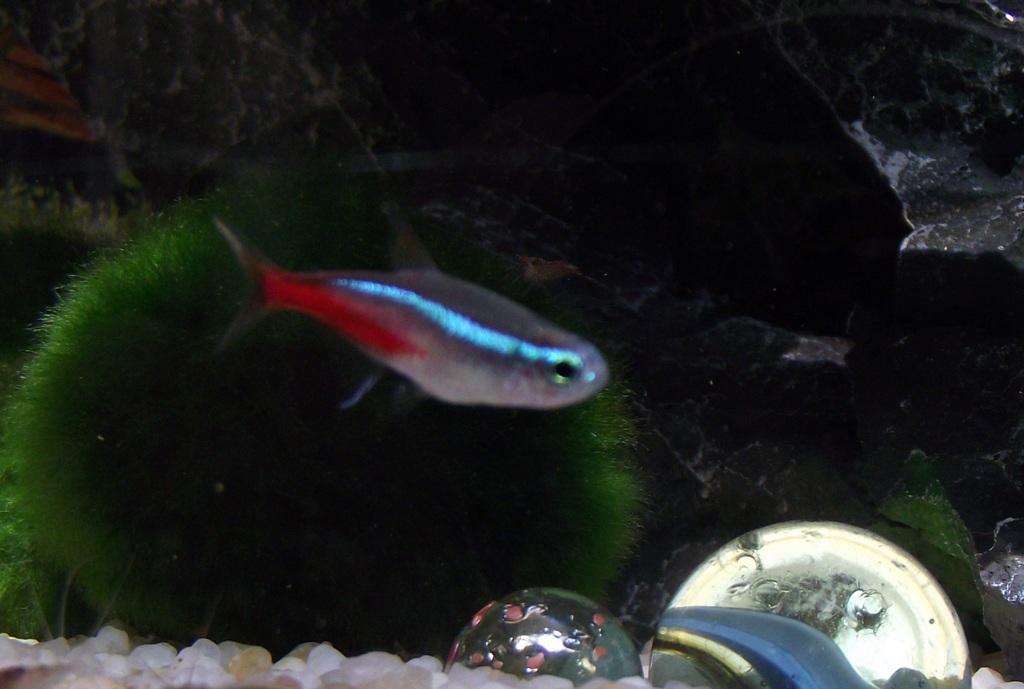Can you describe this image briefly? In this picture there is a fish in the water. At the bottom there are plants, marbles and pebbles in the water and the fish in blue and in red and in grey color. 